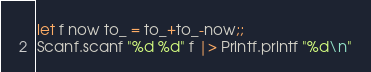Convert code to text. <code><loc_0><loc_0><loc_500><loc_500><_OCaml_>let f now to_ = to_+to_-now;;
Scanf.scanf "%d %d" f |> Printf.printf "%d\n"</code> 